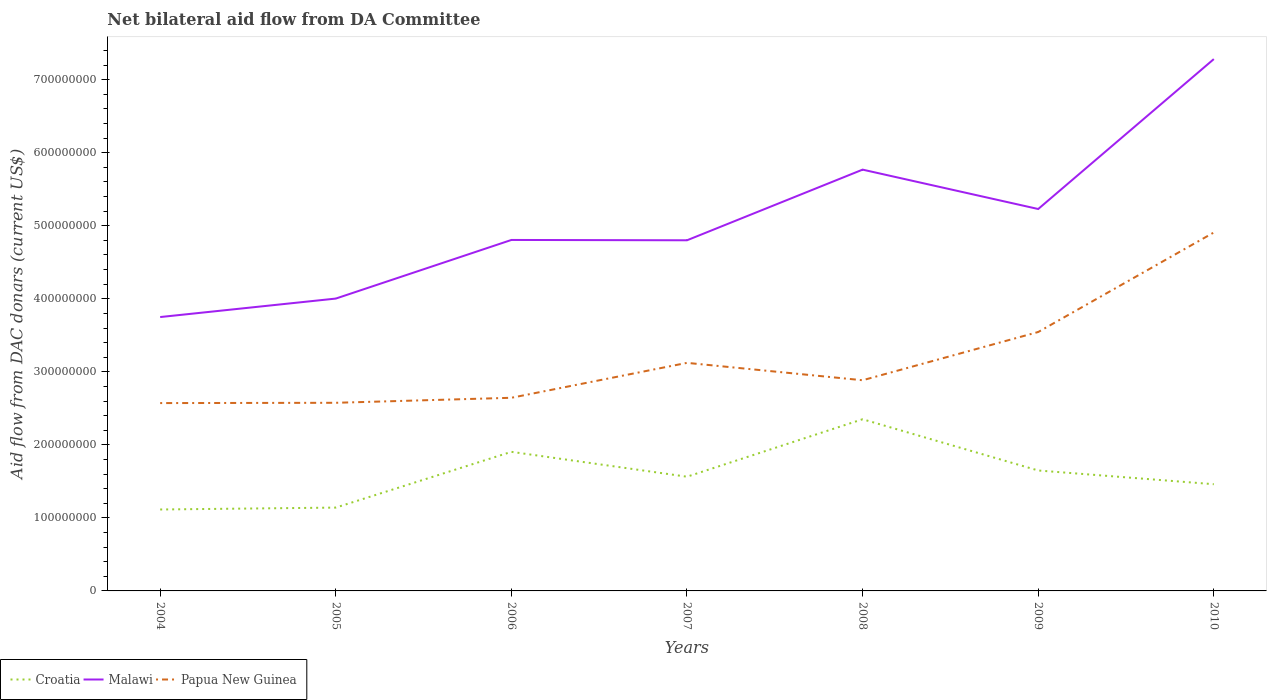How many different coloured lines are there?
Give a very brief answer. 3. Does the line corresponding to Malawi intersect with the line corresponding to Croatia?
Your response must be concise. No. Is the number of lines equal to the number of legend labels?
Ensure brevity in your answer.  Yes. Across all years, what is the maximum aid flow in in Malawi?
Keep it short and to the point. 3.75e+08. What is the total aid flow in in Malawi in the graph?
Give a very brief answer. -2.48e+08. What is the difference between the highest and the second highest aid flow in in Papua New Guinea?
Provide a succinct answer. 2.34e+08. How many lines are there?
Offer a terse response. 3. Does the graph contain any zero values?
Make the answer very short. No. Where does the legend appear in the graph?
Provide a succinct answer. Bottom left. How are the legend labels stacked?
Offer a very short reply. Horizontal. What is the title of the graph?
Your response must be concise. Net bilateral aid flow from DA Committee. Does "Norway" appear as one of the legend labels in the graph?
Offer a terse response. No. What is the label or title of the X-axis?
Ensure brevity in your answer.  Years. What is the label or title of the Y-axis?
Your answer should be very brief. Aid flow from DAC donars (current US$). What is the Aid flow from DAC donars (current US$) of Croatia in 2004?
Offer a terse response. 1.12e+08. What is the Aid flow from DAC donars (current US$) of Malawi in 2004?
Your answer should be compact. 3.75e+08. What is the Aid flow from DAC donars (current US$) in Papua New Guinea in 2004?
Provide a short and direct response. 2.57e+08. What is the Aid flow from DAC donars (current US$) in Croatia in 2005?
Offer a terse response. 1.14e+08. What is the Aid flow from DAC donars (current US$) of Malawi in 2005?
Offer a terse response. 4.00e+08. What is the Aid flow from DAC donars (current US$) in Papua New Guinea in 2005?
Offer a very short reply. 2.58e+08. What is the Aid flow from DAC donars (current US$) in Croatia in 2006?
Provide a succinct answer. 1.90e+08. What is the Aid flow from DAC donars (current US$) in Malawi in 2006?
Provide a succinct answer. 4.81e+08. What is the Aid flow from DAC donars (current US$) in Papua New Guinea in 2006?
Your answer should be very brief. 2.64e+08. What is the Aid flow from DAC donars (current US$) of Croatia in 2007?
Make the answer very short. 1.56e+08. What is the Aid flow from DAC donars (current US$) of Malawi in 2007?
Keep it short and to the point. 4.80e+08. What is the Aid flow from DAC donars (current US$) of Papua New Guinea in 2007?
Your answer should be compact. 3.12e+08. What is the Aid flow from DAC donars (current US$) in Croatia in 2008?
Offer a terse response. 2.35e+08. What is the Aid flow from DAC donars (current US$) of Malawi in 2008?
Keep it short and to the point. 5.77e+08. What is the Aid flow from DAC donars (current US$) in Papua New Guinea in 2008?
Offer a terse response. 2.88e+08. What is the Aid flow from DAC donars (current US$) of Croatia in 2009?
Your answer should be very brief. 1.65e+08. What is the Aid flow from DAC donars (current US$) in Malawi in 2009?
Provide a short and direct response. 5.23e+08. What is the Aid flow from DAC donars (current US$) of Papua New Guinea in 2009?
Make the answer very short. 3.55e+08. What is the Aid flow from DAC donars (current US$) in Croatia in 2010?
Keep it short and to the point. 1.46e+08. What is the Aid flow from DAC donars (current US$) of Malawi in 2010?
Your answer should be compact. 7.28e+08. What is the Aid flow from DAC donars (current US$) in Papua New Guinea in 2010?
Provide a short and direct response. 4.91e+08. Across all years, what is the maximum Aid flow from DAC donars (current US$) in Croatia?
Make the answer very short. 2.35e+08. Across all years, what is the maximum Aid flow from DAC donars (current US$) of Malawi?
Make the answer very short. 7.28e+08. Across all years, what is the maximum Aid flow from DAC donars (current US$) in Papua New Guinea?
Your response must be concise. 4.91e+08. Across all years, what is the minimum Aid flow from DAC donars (current US$) of Croatia?
Offer a terse response. 1.12e+08. Across all years, what is the minimum Aid flow from DAC donars (current US$) in Malawi?
Provide a succinct answer. 3.75e+08. Across all years, what is the minimum Aid flow from DAC donars (current US$) in Papua New Guinea?
Provide a succinct answer. 2.57e+08. What is the total Aid flow from DAC donars (current US$) in Croatia in the graph?
Ensure brevity in your answer.  1.12e+09. What is the total Aid flow from DAC donars (current US$) of Malawi in the graph?
Your response must be concise. 3.56e+09. What is the total Aid flow from DAC donars (current US$) in Papua New Guinea in the graph?
Offer a terse response. 2.23e+09. What is the difference between the Aid flow from DAC donars (current US$) of Croatia in 2004 and that in 2005?
Your response must be concise. -2.59e+06. What is the difference between the Aid flow from DAC donars (current US$) in Malawi in 2004 and that in 2005?
Offer a very short reply. -2.53e+07. What is the difference between the Aid flow from DAC donars (current US$) of Papua New Guinea in 2004 and that in 2005?
Ensure brevity in your answer.  -3.90e+05. What is the difference between the Aid flow from DAC donars (current US$) in Croatia in 2004 and that in 2006?
Provide a succinct answer. -7.90e+07. What is the difference between the Aid flow from DAC donars (current US$) in Malawi in 2004 and that in 2006?
Provide a short and direct response. -1.06e+08. What is the difference between the Aid flow from DAC donars (current US$) of Papua New Guinea in 2004 and that in 2006?
Make the answer very short. -7.26e+06. What is the difference between the Aid flow from DAC donars (current US$) of Croatia in 2004 and that in 2007?
Your answer should be compact. -4.49e+07. What is the difference between the Aid flow from DAC donars (current US$) in Malawi in 2004 and that in 2007?
Keep it short and to the point. -1.05e+08. What is the difference between the Aid flow from DAC donars (current US$) in Papua New Guinea in 2004 and that in 2007?
Offer a very short reply. -5.51e+07. What is the difference between the Aid flow from DAC donars (current US$) in Croatia in 2004 and that in 2008?
Give a very brief answer. -1.24e+08. What is the difference between the Aid flow from DAC donars (current US$) in Malawi in 2004 and that in 2008?
Your response must be concise. -2.02e+08. What is the difference between the Aid flow from DAC donars (current US$) of Papua New Guinea in 2004 and that in 2008?
Offer a very short reply. -3.13e+07. What is the difference between the Aid flow from DAC donars (current US$) in Croatia in 2004 and that in 2009?
Provide a succinct answer. -5.34e+07. What is the difference between the Aid flow from DAC donars (current US$) of Malawi in 2004 and that in 2009?
Make the answer very short. -1.48e+08. What is the difference between the Aid flow from DAC donars (current US$) of Papua New Guinea in 2004 and that in 2009?
Offer a very short reply. -9.73e+07. What is the difference between the Aid flow from DAC donars (current US$) of Croatia in 2004 and that in 2010?
Offer a very short reply. -3.46e+07. What is the difference between the Aid flow from DAC donars (current US$) of Malawi in 2004 and that in 2010?
Give a very brief answer. -3.53e+08. What is the difference between the Aid flow from DAC donars (current US$) of Papua New Guinea in 2004 and that in 2010?
Offer a very short reply. -2.34e+08. What is the difference between the Aid flow from DAC donars (current US$) in Croatia in 2005 and that in 2006?
Provide a succinct answer. -7.64e+07. What is the difference between the Aid flow from DAC donars (current US$) in Malawi in 2005 and that in 2006?
Your response must be concise. -8.03e+07. What is the difference between the Aid flow from DAC donars (current US$) in Papua New Guinea in 2005 and that in 2006?
Your response must be concise. -6.87e+06. What is the difference between the Aid flow from DAC donars (current US$) of Croatia in 2005 and that in 2007?
Provide a succinct answer. -4.23e+07. What is the difference between the Aid flow from DAC donars (current US$) in Malawi in 2005 and that in 2007?
Keep it short and to the point. -7.98e+07. What is the difference between the Aid flow from DAC donars (current US$) in Papua New Guinea in 2005 and that in 2007?
Your answer should be very brief. -5.47e+07. What is the difference between the Aid flow from DAC donars (current US$) of Croatia in 2005 and that in 2008?
Your answer should be very brief. -1.21e+08. What is the difference between the Aid flow from DAC donars (current US$) in Malawi in 2005 and that in 2008?
Make the answer very short. -1.77e+08. What is the difference between the Aid flow from DAC donars (current US$) of Papua New Guinea in 2005 and that in 2008?
Your answer should be very brief. -3.09e+07. What is the difference between the Aid flow from DAC donars (current US$) in Croatia in 2005 and that in 2009?
Your answer should be very brief. -5.08e+07. What is the difference between the Aid flow from DAC donars (current US$) of Malawi in 2005 and that in 2009?
Make the answer very short. -1.23e+08. What is the difference between the Aid flow from DAC donars (current US$) in Papua New Guinea in 2005 and that in 2009?
Ensure brevity in your answer.  -9.69e+07. What is the difference between the Aid flow from DAC donars (current US$) in Croatia in 2005 and that in 2010?
Offer a very short reply. -3.20e+07. What is the difference between the Aid flow from DAC donars (current US$) in Malawi in 2005 and that in 2010?
Ensure brevity in your answer.  -3.28e+08. What is the difference between the Aid flow from DAC donars (current US$) of Papua New Guinea in 2005 and that in 2010?
Make the answer very short. -2.33e+08. What is the difference between the Aid flow from DAC donars (current US$) of Croatia in 2006 and that in 2007?
Provide a succinct answer. 3.41e+07. What is the difference between the Aid flow from DAC donars (current US$) in Malawi in 2006 and that in 2007?
Ensure brevity in your answer.  4.40e+05. What is the difference between the Aid flow from DAC donars (current US$) in Papua New Guinea in 2006 and that in 2007?
Your response must be concise. -4.78e+07. What is the difference between the Aid flow from DAC donars (current US$) of Croatia in 2006 and that in 2008?
Provide a succinct answer. -4.46e+07. What is the difference between the Aid flow from DAC donars (current US$) in Malawi in 2006 and that in 2008?
Offer a terse response. -9.63e+07. What is the difference between the Aid flow from DAC donars (current US$) in Papua New Guinea in 2006 and that in 2008?
Offer a very short reply. -2.40e+07. What is the difference between the Aid flow from DAC donars (current US$) in Croatia in 2006 and that in 2009?
Give a very brief answer. 2.56e+07. What is the difference between the Aid flow from DAC donars (current US$) of Malawi in 2006 and that in 2009?
Provide a succinct answer. -4.24e+07. What is the difference between the Aid flow from DAC donars (current US$) in Papua New Guinea in 2006 and that in 2009?
Your response must be concise. -9.01e+07. What is the difference between the Aid flow from DAC donars (current US$) in Croatia in 2006 and that in 2010?
Provide a short and direct response. 4.43e+07. What is the difference between the Aid flow from DAC donars (current US$) in Malawi in 2006 and that in 2010?
Your response must be concise. -2.48e+08. What is the difference between the Aid flow from DAC donars (current US$) of Papua New Guinea in 2006 and that in 2010?
Ensure brevity in your answer.  -2.26e+08. What is the difference between the Aid flow from DAC donars (current US$) of Croatia in 2007 and that in 2008?
Your response must be concise. -7.87e+07. What is the difference between the Aid flow from DAC donars (current US$) in Malawi in 2007 and that in 2008?
Make the answer very short. -9.67e+07. What is the difference between the Aid flow from DAC donars (current US$) in Papua New Guinea in 2007 and that in 2008?
Give a very brief answer. 2.38e+07. What is the difference between the Aid flow from DAC donars (current US$) in Croatia in 2007 and that in 2009?
Offer a very short reply. -8.51e+06. What is the difference between the Aid flow from DAC donars (current US$) of Malawi in 2007 and that in 2009?
Your answer should be very brief. -4.28e+07. What is the difference between the Aid flow from DAC donars (current US$) in Papua New Guinea in 2007 and that in 2009?
Keep it short and to the point. -4.22e+07. What is the difference between the Aid flow from DAC donars (current US$) of Croatia in 2007 and that in 2010?
Provide a short and direct response. 1.03e+07. What is the difference between the Aid flow from DAC donars (current US$) in Malawi in 2007 and that in 2010?
Ensure brevity in your answer.  -2.48e+08. What is the difference between the Aid flow from DAC donars (current US$) of Papua New Guinea in 2007 and that in 2010?
Offer a terse response. -1.78e+08. What is the difference between the Aid flow from DAC donars (current US$) in Croatia in 2008 and that in 2009?
Your answer should be very brief. 7.02e+07. What is the difference between the Aid flow from DAC donars (current US$) of Malawi in 2008 and that in 2009?
Your answer should be compact. 5.39e+07. What is the difference between the Aid flow from DAC donars (current US$) in Papua New Guinea in 2008 and that in 2009?
Keep it short and to the point. -6.60e+07. What is the difference between the Aid flow from DAC donars (current US$) in Croatia in 2008 and that in 2010?
Offer a terse response. 8.90e+07. What is the difference between the Aid flow from DAC donars (current US$) of Malawi in 2008 and that in 2010?
Provide a short and direct response. -1.51e+08. What is the difference between the Aid flow from DAC donars (current US$) of Papua New Guinea in 2008 and that in 2010?
Ensure brevity in your answer.  -2.02e+08. What is the difference between the Aid flow from DAC donars (current US$) in Croatia in 2009 and that in 2010?
Your answer should be compact. 1.88e+07. What is the difference between the Aid flow from DAC donars (current US$) in Malawi in 2009 and that in 2010?
Make the answer very short. -2.05e+08. What is the difference between the Aid flow from DAC donars (current US$) of Papua New Guinea in 2009 and that in 2010?
Give a very brief answer. -1.36e+08. What is the difference between the Aid flow from DAC donars (current US$) of Croatia in 2004 and the Aid flow from DAC donars (current US$) of Malawi in 2005?
Your response must be concise. -2.89e+08. What is the difference between the Aid flow from DAC donars (current US$) of Croatia in 2004 and the Aid flow from DAC donars (current US$) of Papua New Guinea in 2005?
Offer a very short reply. -1.46e+08. What is the difference between the Aid flow from DAC donars (current US$) of Malawi in 2004 and the Aid flow from DAC donars (current US$) of Papua New Guinea in 2005?
Your answer should be very brief. 1.17e+08. What is the difference between the Aid flow from DAC donars (current US$) in Croatia in 2004 and the Aid flow from DAC donars (current US$) in Malawi in 2006?
Keep it short and to the point. -3.69e+08. What is the difference between the Aid flow from DAC donars (current US$) of Croatia in 2004 and the Aid flow from DAC donars (current US$) of Papua New Guinea in 2006?
Provide a short and direct response. -1.53e+08. What is the difference between the Aid flow from DAC donars (current US$) of Malawi in 2004 and the Aid flow from DAC donars (current US$) of Papua New Guinea in 2006?
Offer a very short reply. 1.11e+08. What is the difference between the Aid flow from DAC donars (current US$) in Croatia in 2004 and the Aid flow from DAC donars (current US$) in Malawi in 2007?
Give a very brief answer. -3.69e+08. What is the difference between the Aid flow from DAC donars (current US$) of Croatia in 2004 and the Aid flow from DAC donars (current US$) of Papua New Guinea in 2007?
Give a very brief answer. -2.01e+08. What is the difference between the Aid flow from DAC donars (current US$) of Malawi in 2004 and the Aid flow from DAC donars (current US$) of Papua New Guinea in 2007?
Ensure brevity in your answer.  6.27e+07. What is the difference between the Aid flow from DAC donars (current US$) of Croatia in 2004 and the Aid flow from DAC donars (current US$) of Malawi in 2008?
Your answer should be very brief. -4.65e+08. What is the difference between the Aid flow from DAC donars (current US$) of Croatia in 2004 and the Aid flow from DAC donars (current US$) of Papua New Guinea in 2008?
Provide a short and direct response. -1.77e+08. What is the difference between the Aid flow from DAC donars (current US$) of Malawi in 2004 and the Aid flow from DAC donars (current US$) of Papua New Guinea in 2008?
Offer a terse response. 8.65e+07. What is the difference between the Aid flow from DAC donars (current US$) in Croatia in 2004 and the Aid flow from DAC donars (current US$) in Malawi in 2009?
Keep it short and to the point. -4.11e+08. What is the difference between the Aid flow from DAC donars (current US$) of Croatia in 2004 and the Aid flow from DAC donars (current US$) of Papua New Guinea in 2009?
Your answer should be very brief. -2.43e+08. What is the difference between the Aid flow from DAC donars (current US$) of Malawi in 2004 and the Aid flow from DAC donars (current US$) of Papua New Guinea in 2009?
Keep it short and to the point. 2.05e+07. What is the difference between the Aid flow from DAC donars (current US$) in Croatia in 2004 and the Aid flow from DAC donars (current US$) in Malawi in 2010?
Offer a very short reply. -6.17e+08. What is the difference between the Aid flow from DAC donars (current US$) in Croatia in 2004 and the Aid flow from DAC donars (current US$) in Papua New Guinea in 2010?
Offer a terse response. -3.79e+08. What is the difference between the Aid flow from DAC donars (current US$) of Malawi in 2004 and the Aid flow from DAC donars (current US$) of Papua New Guinea in 2010?
Keep it short and to the point. -1.16e+08. What is the difference between the Aid flow from DAC donars (current US$) of Croatia in 2005 and the Aid flow from DAC donars (current US$) of Malawi in 2006?
Your response must be concise. -3.66e+08. What is the difference between the Aid flow from DAC donars (current US$) of Croatia in 2005 and the Aid flow from DAC donars (current US$) of Papua New Guinea in 2006?
Offer a very short reply. -1.50e+08. What is the difference between the Aid flow from DAC donars (current US$) in Malawi in 2005 and the Aid flow from DAC donars (current US$) in Papua New Guinea in 2006?
Your answer should be very brief. 1.36e+08. What is the difference between the Aid flow from DAC donars (current US$) in Croatia in 2005 and the Aid flow from DAC donars (current US$) in Malawi in 2007?
Give a very brief answer. -3.66e+08. What is the difference between the Aid flow from DAC donars (current US$) of Croatia in 2005 and the Aid flow from DAC donars (current US$) of Papua New Guinea in 2007?
Your answer should be compact. -1.98e+08. What is the difference between the Aid flow from DAC donars (current US$) of Malawi in 2005 and the Aid flow from DAC donars (current US$) of Papua New Guinea in 2007?
Offer a very short reply. 8.80e+07. What is the difference between the Aid flow from DAC donars (current US$) in Croatia in 2005 and the Aid flow from DAC donars (current US$) in Malawi in 2008?
Provide a succinct answer. -4.63e+08. What is the difference between the Aid flow from DAC donars (current US$) of Croatia in 2005 and the Aid flow from DAC donars (current US$) of Papua New Guinea in 2008?
Keep it short and to the point. -1.74e+08. What is the difference between the Aid flow from DAC donars (current US$) of Malawi in 2005 and the Aid flow from DAC donars (current US$) of Papua New Guinea in 2008?
Offer a very short reply. 1.12e+08. What is the difference between the Aid flow from DAC donars (current US$) of Croatia in 2005 and the Aid flow from DAC donars (current US$) of Malawi in 2009?
Make the answer very short. -4.09e+08. What is the difference between the Aid flow from DAC donars (current US$) in Croatia in 2005 and the Aid flow from DAC donars (current US$) in Papua New Guinea in 2009?
Ensure brevity in your answer.  -2.40e+08. What is the difference between the Aid flow from DAC donars (current US$) in Malawi in 2005 and the Aid flow from DAC donars (current US$) in Papua New Guinea in 2009?
Provide a succinct answer. 4.58e+07. What is the difference between the Aid flow from DAC donars (current US$) in Croatia in 2005 and the Aid flow from DAC donars (current US$) in Malawi in 2010?
Your response must be concise. -6.14e+08. What is the difference between the Aid flow from DAC donars (current US$) of Croatia in 2005 and the Aid flow from DAC donars (current US$) of Papua New Guinea in 2010?
Provide a short and direct response. -3.77e+08. What is the difference between the Aid flow from DAC donars (current US$) in Malawi in 2005 and the Aid flow from DAC donars (current US$) in Papua New Guinea in 2010?
Provide a succinct answer. -9.05e+07. What is the difference between the Aid flow from DAC donars (current US$) in Croatia in 2006 and the Aid flow from DAC donars (current US$) in Malawi in 2007?
Offer a terse response. -2.90e+08. What is the difference between the Aid flow from DAC donars (current US$) of Croatia in 2006 and the Aid flow from DAC donars (current US$) of Papua New Guinea in 2007?
Provide a short and direct response. -1.22e+08. What is the difference between the Aid flow from DAC donars (current US$) in Malawi in 2006 and the Aid flow from DAC donars (current US$) in Papua New Guinea in 2007?
Offer a very short reply. 1.68e+08. What is the difference between the Aid flow from DAC donars (current US$) of Croatia in 2006 and the Aid flow from DAC donars (current US$) of Malawi in 2008?
Provide a succinct answer. -3.86e+08. What is the difference between the Aid flow from DAC donars (current US$) in Croatia in 2006 and the Aid flow from DAC donars (current US$) in Papua New Guinea in 2008?
Your answer should be compact. -9.80e+07. What is the difference between the Aid flow from DAC donars (current US$) of Malawi in 2006 and the Aid flow from DAC donars (current US$) of Papua New Guinea in 2008?
Your response must be concise. 1.92e+08. What is the difference between the Aid flow from DAC donars (current US$) of Croatia in 2006 and the Aid flow from DAC donars (current US$) of Malawi in 2009?
Give a very brief answer. -3.32e+08. What is the difference between the Aid flow from DAC donars (current US$) of Croatia in 2006 and the Aid flow from DAC donars (current US$) of Papua New Guinea in 2009?
Give a very brief answer. -1.64e+08. What is the difference between the Aid flow from DAC donars (current US$) in Malawi in 2006 and the Aid flow from DAC donars (current US$) in Papua New Guinea in 2009?
Keep it short and to the point. 1.26e+08. What is the difference between the Aid flow from DAC donars (current US$) of Croatia in 2006 and the Aid flow from DAC donars (current US$) of Malawi in 2010?
Your answer should be very brief. -5.38e+08. What is the difference between the Aid flow from DAC donars (current US$) in Croatia in 2006 and the Aid flow from DAC donars (current US$) in Papua New Guinea in 2010?
Give a very brief answer. -3.00e+08. What is the difference between the Aid flow from DAC donars (current US$) in Malawi in 2006 and the Aid flow from DAC donars (current US$) in Papua New Guinea in 2010?
Ensure brevity in your answer.  -1.02e+07. What is the difference between the Aid flow from DAC donars (current US$) of Croatia in 2007 and the Aid flow from DAC donars (current US$) of Malawi in 2008?
Your response must be concise. -4.20e+08. What is the difference between the Aid flow from DAC donars (current US$) in Croatia in 2007 and the Aid flow from DAC donars (current US$) in Papua New Guinea in 2008?
Give a very brief answer. -1.32e+08. What is the difference between the Aid flow from DAC donars (current US$) in Malawi in 2007 and the Aid flow from DAC donars (current US$) in Papua New Guinea in 2008?
Ensure brevity in your answer.  1.92e+08. What is the difference between the Aid flow from DAC donars (current US$) in Croatia in 2007 and the Aid flow from DAC donars (current US$) in Malawi in 2009?
Make the answer very short. -3.67e+08. What is the difference between the Aid flow from DAC donars (current US$) in Croatia in 2007 and the Aid flow from DAC donars (current US$) in Papua New Guinea in 2009?
Your response must be concise. -1.98e+08. What is the difference between the Aid flow from DAC donars (current US$) in Malawi in 2007 and the Aid flow from DAC donars (current US$) in Papua New Guinea in 2009?
Keep it short and to the point. 1.26e+08. What is the difference between the Aid flow from DAC donars (current US$) of Croatia in 2007 and the Aid flow from DAC donars (current US$) of Malawi in 2010?
Make the answer very short. -5.72e+08. What is the difference between the Aid flow from DAC donars (current US$) in Croatia in 2007 and the Aid flow from DAC donars (current US$) in Papua New Guinea in 2010?
Keep it short and to the point. -3.34e+08. What is the difference between the Aid flow from DAC donars (current US$) of Malawi in 2007 and the Aid flow from DAC donars (current US$) of Papua New Guinea in 2010?
Provide a short and direct response. -1.06e+07. What is the difference between the Aid flow from DAC donars (current US$) of Croatia in 2008 and the Aid flow from DAC donars (current US$) of Malawi in 2009?
Provide a short and direct response. -2.88e+08. What is the difference between the Aid flow from DAC donars (current US$) in Croatia in 2008 and the Aid flow from DAC donars (current US$) in Papua New Guinea in 2009?
Keep it short and to the point. -1.19e+08. What is the difference between the Aid flow from DAC donars (current US$) of Malawi in 2008 and the Aid flow from DAC donars (current US$) of Papua New Guinea in 2009?
Provide a succinct answer. 2.22e+08. What is the difference between the Aid flow from DAC donars (current US$) of Croatia in 2008 and the Aid flow from DAC donars (current US$) of Malawi in 2010?
Offer a terse response. -4.93e+08. What is the difference between the Aid flow from DAC donars (current US$) of Croatia in 2008 and the Aid flow from DAC donars (current US$) of Papua New Guinea in 2010?
Keep it short and to the point. -2.56e+08. What is the difference between the Aid flow from DAC donars (current US$) in Malawi in 2008 and the Aid flow from DAC donars (current US$) in Papua New Guinea in 2010?
Your response must be concise. 8.61e+07. What is the difference between the Aid flow from DAC donars (current US$) in Croatia in 2009 and the Aid flow from DAC donars (current US$) in Malawi in 2010?
Keep it short and to the point. -5.63e+08. What is the difference between the Aid flow from DAC donars (current US$) in Croatia in 2009 and the Aid flow from DAC donars (current US$) in Papua New Guinea in 2010?
Ensure brevity in your answer.  -3.26e+08. What is the difference between the Aid flow from DAC donars (current US$) of Malawi in 2009 and the Aid flow from DAC donars (current US$) of Papua New Guinea in 2010?
Your response must be concise. 3.22e+07. What is the average Aid flow from DAC donars (current US$) of Croatia per year?
Make the answer very short. 1.60e+08. What is the average Aid flow from DAC donars (current US$) in Malawi per year?
Give a very brief answer. 5.09e+08. What is the average Aid flow from DAC donars (current US$) in Papua New Guinea per year?
Provide a succinct answer. 3.18e+08. In the year 2004, what is the difference between the Aid flow from DAC donars (current US$) of Croatia and Aid flow from DAC donars (current US$) of Malawi?
Give a very brief answer. -2.64e+08. In the year 2004, what is the difference between the Aid flow from DAC donars (current US$) in Croatia and Aid flow from DAC donars (current US$) in Papua New Guinea?
Your answer should be compact. -1.46e+08. In the year 2004, what is the difference between the Aid flow from DAC donars (current US$) of Malawi and Aid flow from DAC donars (current US$) of Papua New Guinea?
Provide a short and direct response. 1.18e+08. In the year 2005, what is the difference between the Aid flow from DAC donars (current US$) of Croatia and Aid flow from DAC donars (current US$) of Malawi?
Keep it short and to the point. -2.86e+08. In the year 2005, what is the difference between the Aid flow from DAC donars (current US$) in Croatia and Aid flow from DAC donars (current US$) in Papua New Guinea?
Offer a terse response. -1.44e+08. In the year 2005, what is the difference between the Aid flow from DAC donars (current US$) in Malawi and Aid flow from DAC donars (current US$) in Papua New Guinea?
Ensure brevity in your answer.  1.43e+08. In the year 2006, what is the difference between the Aid flow from DAC donars (current US$) in Croatia and Aid flow from DAC donars (current US$) in Malawi?
Your answer should be very brief. -2.90e+08. In the year 2006, what is the difference between the Aid flow from DAC donars (current US$) of Croatia and Aid flow from DAC donars (current US$) of Papua New Guinea?
Provide a succinct answer. -7.40e+07. In the year 2006, what is the difference between the Aid flow from DAC donars (current US$) in Malawi and Aid flow from DAC donars (current US$) in Papua New Guinea?
Your response must be concise. 2.16e+08. In the year 2007, what is the difference between the Aid flow from DAC donars (current US$) of Croatia and Aid flow from DAC donars (current US$) of Malawi?
Your answer should be very brief. -3.24e+08. In the year 2007, what is the difference between the Aid flow from DAC donars (current US$) of Croatia and Aid flow from DAC donars (current US$) of Papua New Guinea?
Make the answer very short. -1.56e+08. In the year 2007, what is the difference between the Aid flow from DAC donars (current US$) in Malawi and Aid flow from DAC donars (current US$) in Papua New Guinea?
Give a very brief answer. 1.68e+08. In the year 2008, what is the difference between the Aid flow from DAC donars (current US$) in Croatia and Aid flow from DAC donars (current US$) in Malawi?
Keep it short and to the point. -3.42e+08. In the year 2008, what is the difference between the Aid flow from DAC donars (current US$) in Croatia and Aid flow from DAC donars (current US$) in Papua New Guinea?
Make the answer very short. -5.34e+07. In the year 2008, what is the difference between the Aid flow from DAC donars (current US$) of Malawi and Aid flow from DAC donars (current US$) of Papua New Guinea?
Provide a short and direct response. 2.88e+08. In the year 2009, what is the difference between the Aid flow from DAC donars (current US$) in Croatia and Aid flow from DAC donars (current US$) in Malawi?
Provide a succinct answer. -3.58e+08. In the year 2009, what is the difference between the Aid flow from DAC donars (current US$) of Croatia and Aid flow from DAC donars (current US$) of Papua New Guinea?
Keep it short and to the point. -1.90e+08. In the year 2009, what is the difference between the Aid flow from DAC donars (current US$) of Malawi and Aid flow from DAC donars (current US$) of Papua New Guinea?
Your response must be concise. 1.68e+08. In the year 2010, what is the difference between the Aid flow from DAC donars (current US$) of Croatia and Aid flow from DAC donars (current US$) of Malawi?
Offer a very short reply. -5.82e+08. In the year 2010, what is the difference between the Aid flow from DAC donars (current US$) of Croatia and Aid flow from DAC donars (current US$) of Papua New Guinea?
Offer a very short reply. -3.45e+08. In the year 2010, what is the difference between the Aid flow from DAC donars (current US$) in Malawi and Aid flow from DAC donars (current US$) in Papua New Guinea?
Make the answer very short. 2.37e+08. What is the ratio of the Aid flow from DAC donars (current US$) of Croatia in 2004 to that in 2005?
Offer a terse response. 0.98. What is the ratio of the Aid flow from DAC donars (current US$) in Malawi in 2004 to that in 2005?
Make the answer very short. 0.94. What is the ratio of the Aid flow from DAC donars (current US$) of Croatia in 2004 to that in 2006?
Your answer should be compact. 0.59. What is the ratio of the Aid flow from DAC donars (current US$) of Malawi in 2004 to that in 2006?
Ensure brevity in your answer.  0.78. What is the ratio of the Aid flow from DAC donars (current US$) of Papua New Guinea in 2004 to that in 2006?
Offer a very short reply. 0.97. What is the ratio of the Aid flow from DAC donars (current US$) of Croatia in 2004 to that in 2007?
Offer a terse response. 0.71. What is the ratio of the Aid flow from DAC donars (current US$) in Malawi in 2004 to that in 2007?
Your answer should be very brief. 0.78. What is the ratio of the Aid flow from DAC donars (current US$) of Papua New Guinea in 2004 to that in 2007?
Your response must be concise. 0.82. What is the ratio of the Aid flow from DAC donars (current US$) in Croatia in 2004 to that in 2008?
Your answer should be very brief. 0.47. What is the ratio of the Aid flow from DAC donars (current US$) of Malawi in 2004 to that in 2008?
Provide a succinct answer. 0.65. What is the ratio of the Aid flow from DAC donars (current US$) of Papua New Guinea in 2004 to that in 2008?
Your answer should be very brief. 0.89. What is the ratio of the Aid flow from DAC donars (current US$) in Croatia in 2004 to that in 2009?
Your answer should be compact. 0.68. What is the ratio of the Aid flow from DAC donars (current US$) of Malawi in 2004 to that in 2009?
Provide a short and direct response. 0.72. What is the ratio of the Aid flow from DAC donars (current US$) of Papua New Guinea in 2004 to that in 2009?
Keep it short and to the point. 0.73. What is the ratio of the Aid flow from DAC donars (current US$) of Croatia in 2004 to that in 2010?
Provide a short and direct response. 0.76. What is the ratio of the Aid flow from DAC donars (current US$) of Malawi in 2004 to that in 2010?
Provide a succinct answer. 0.52. What is the ratio of the Aid flow from DAC donars (current US$) of Papua New Guinea in 2004 to that in 2010?
Your answer should be compact. 0.52. What is the ratio of the Aid flow from DAC donars (current US$) in Croatia in 2005 to that in 2006?
Keep it short and to the point. 0.6. What is the ratio of the Aid flow from DAC donars (current US$) of Malawi in 2005 to that in 2006?
Make the answer very short. 0.83. What is the ratio of the Aid flow from DAC donars (current US$) of Papua New Guinea in 2005 to that in 2006?
Provide a succinct answer. 0.97. What is the ratio of the Aid flow from DAC donars (current US$) in Croatia in 2005 to that in 2007?
Your answer should be compact. 0.73. What is the ratio of the Aid flow from DAC donars (current US$) of Malawi in 2005 to that in 2007?
Keep it short and to the point. 0.83. What is the ratio of the Aid flow from DAC donars (current US$) in Papua New Guinea in 2005 to that in 2007?
Your answer should be very brief. 0.82. What is the ratio of the Aid flow from DAC donars (current US$) in Croatia in 2005 to that in 2008?
Keep it short and to the point. 0.49. What is the ratio of the Aid flow from DAC donars (current US$) of Malawi in 2005 to that in 2008?
Offer a very short reply. 0.69. What is the ratio of the Aid flow from DAC donars (current US$) in Papua New Guinea in 2005 to that in 2008?
Ensure brevity in your answer.  0.89. What is the ratio of the Aid flow from DAC donars (current US$) in Croatia in 2005 to that in 2009?
Keep it short and to the point. 0.69. What is the ratio of the Aid flow from DAC donars (current US$) of Malawi in 2005 to that in 2009?
Give a very brief answer. 0.77. What is the ratio of the Aid flow from DAC donars (current US$) in Papua New Guinea in 2005 to that in 2009?
Provide a succinct answer. 0.73. What is the ratio of the Aid flow from DAC donars (current US$) of Croatia in 2005 to that in 2010?
Ensure brevity in your answer.  0.78. What is the ratio of the Aid flow from DAC donars (current US$) in Malawi in 2005 to that in 2010?
Give a very brief answer. 0.55. What is the ratio of the Aid flow from DAC donars (current US$) of Papua New Guinea in 2005 to that in 2010?
Your response must be concise. 0.52. What is the ratio of the Aid flow from DAC donars (current US$) of Croatia in 2006 to that in 2007?
Offer a very short reply. 1.22. What is the ratio of the Aid flow from DAC donars (current US$) in Papua New Guinea in 2006 to that in 2007?
Ensure brevity in your answer.  0.85. What is the ratio of the Aid flow from DAC donars (current US$) in Croatia in 2006 to that in 2008?
Your answer should be very brief. 0.81. What is the ratio of the Aid flow from DAC donars (current US$) in Malawi in 2006 to that in 2008?
Give a very brief answer. 0.83. What is the ratio of the Aid flow from DAC donars (current US$) of Croatia in 2006 to that in 2009?
Provide a short and direct response. 1.15. What is the ratio of the Aid flow from DAC donars (current US$) of Malawi in 2006 to that in 2009?
Ensure brevity in your answer.  0.92. What is the ratio of the Aid flow from DAC donars (current US$) in Papua New Guinea in 2006 to that in 2009?
Offer a terse response. 0.75. What is the ratio of the Aid flow from DAC donars (current US$) of Croatia in 2006 to that in 2010?
Offer a terse response. 1.3. What is the ratio of the Aid flow from DAC donars (current US$) in Malawi in 2006 to that in 2010?
Give a very brief answer. 0.66. What is the ratio of the Aid flow from DAC donars (current US$) of Papua New Guinea in 2006 to that in 2010?
Offer a terse response. 0.54. What is the ratio of the Aid flow from DAC donars (current US$) of Croatia in 2007 to that in 2008?
Your response must be concise. 0.67. What is the ratio of the Aid flow from DAC donars (current US$) of Malawi in 2007 to that in 2008?
Provide a succinct answer. 0.83. What is the ratio of the Aid flow from DAC donars (current US$) of Papua New Guinea in 2007 to that in 2008?
Your answer should be compact. 1.08. What is the ratio of the Aid flow from DAC donars (current US$) in Croatia in 2007 to that in 2009?
Ensure brevity in your answer.  0.95. What is the ratio of the Aid flow from DAC donars (current US$) in Malawi in 2007 to that in 2009?
Your answer should be compact. 0.92. What is the ratio of the Aid flow from DAC donars (current US$) of Papua New Guinea in 2007 to that in 2009?
Your answer should be very brief. 0.88. What is the ratio of the Aid flow from DAC donars (current US$) in Croatia in 2007 to that in 2010?
Your answer should be very brief. 1.07. What is the ratio of the Aid flow from DAC donars (current US$) in Malawi in 2007 to that in 2010?
Make the answer very short. 0.66. What is the ratio of the Aid flow from DAC donars (current US$) in Papua New Guinea in 2007 to that in 2010?
Give a very brief answer. 0.64. What is the ratio of the Aid flow from DAC donars (current US$) in Croatia in 2008 to that in 2009?
Provide a succinct answer. 1.43. What is the ratio of the Aid flow from DAC donars (current US$) in Malawi in 2008 to that in 2009?
Give a very brief answer. 1.1. What is the ratio of the Aid flow from DAC donars (current US$) of Papua New Guinea in 2008 to that in 2009?
Your response must be concise. 0.81. What is the ratio of the Aid flow from DAC donars (current US$) in Croatia in 2008 to that in 2010?
Your response must be concise. 1.61. What is the ratio of the Aid flow from DAC donars (current US$) in Malawi in 2008 to that in 2010?
Give a very brief answer. 0.79. What is the ratio of the Aid flow from DAC donars (current US$) of Papua New Guinea in 2008 to that in 2010?
Ensure brevity in your answer.  0.59. What is the ratio of the Aid flow from DAC donars (current US$) in Croatia in 2009 to that in 2010?
Keep it short and to the point. 1.13. What is the ratio of the Aid flow from DAC donars (current US$) of Malawi in 2009 to that in 2010?
Provide a succinct answer. 0.72. What is the ratio of the Aid flow from DAC donars (current US$) of Papua New Guinea in 2009 to that in 2010?
Your answer should be compact. 0.72. What is the difference between the highest and the second highest Aid flow from DAC donars (current US$) in Croatia?
Provide a succinct answer. 4.46e+07. What is the difference between the highest and the second highest Aid flow from DAC donars (current US$) of Malawi?
Offer a terse response. 1.51e+08. What is the difference between the highest and the second highest Aid flow from DAC donars (current US$) of Papua New Guinea?
Ensure brevity in your answer.  1.36e+08. What is the difference between the highest and the lowest Aid flow from DAC donars (current US$) of Croatia?
Make the answer very short. 1.24e+08. What is the difference between the highest and the lowest Aid flow from DAC donars (current US$) in Malawi?
Give a very brief answer. 3.53e+08. What is the difference between the highest and the lowest Aid flow from DAC donars (current US$) in Papua New Guinea?
Provide a short and direct response. 2.34e+08. 